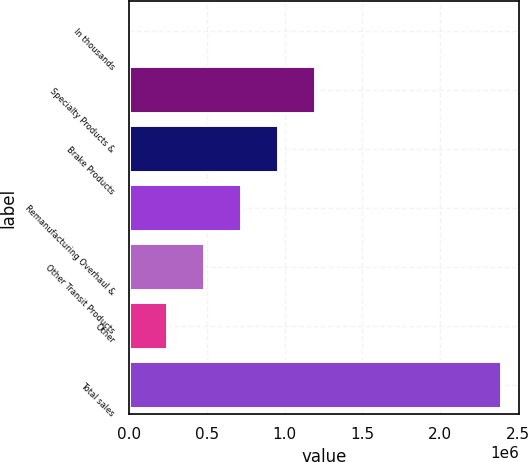<chart> <loc_0><loc_0><loc_500><loc_500><bar_chart><fcel>In thousands<fcel>Specialty Products &<fcel>Brake Products<fcel>Remanufacturing Overhaul &<fcel>Other Transit Products<fcel>Other<fcel>Total sales<nl><fcel>2012<fcel>1.19657e+06<fcel>957656<fcel>718745<fcel>479834<fcel>240923<fcel>2.39112e+06<nl></chart> 